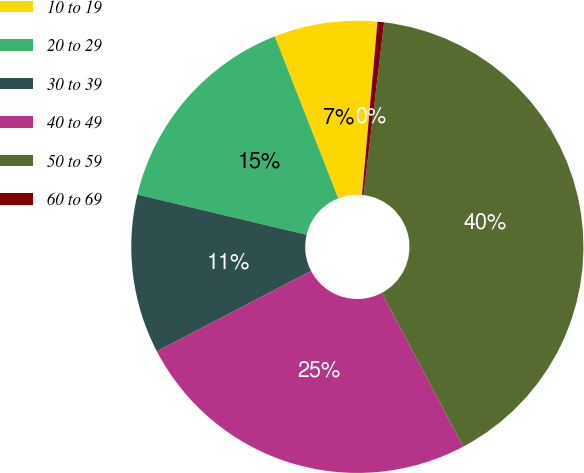Convert chart. <chart><loc_0><loc_0><loc_500><loc_500><pie_chart><fcel>10 to 19<fcel>20 to 29<fcel>30 to 39<fcel>40 to 49<fcel>50 to 59<fcel>60 to 69<nl><fcel>7.37%<fcel>15.34%<fcel>11.36%<fcel>25.12%<fcel>40.35%<fcel>0.47%<nl></chart> 